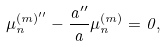Convert formula to latex. <formula><loc_0><loc_0><loc_500><loc_500>\mu ^ { ( m ) ^ { \prime \prime } } _ { n } - \frac { a ^ { \prime \prime } } { a } \mu ^ { ( m ) } _ { n } = 0 ,</formula> 